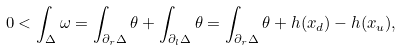<formula> <loc_0><loc_0><loc_500><loc_500>0 < \int _ { \Delta } \omega = \int _ { \partial _ { r } \Delta } \theta + \int _ { \partial _ { l } \Delta } \theta = \int _ { \partial _ { r } \Delta } \theta + h ( x _ { d } ) - h ( x _ { u } ) ,</formula> 